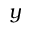<formula> <loc_0><loc_0><loc_500><loc_500>y</formula> 